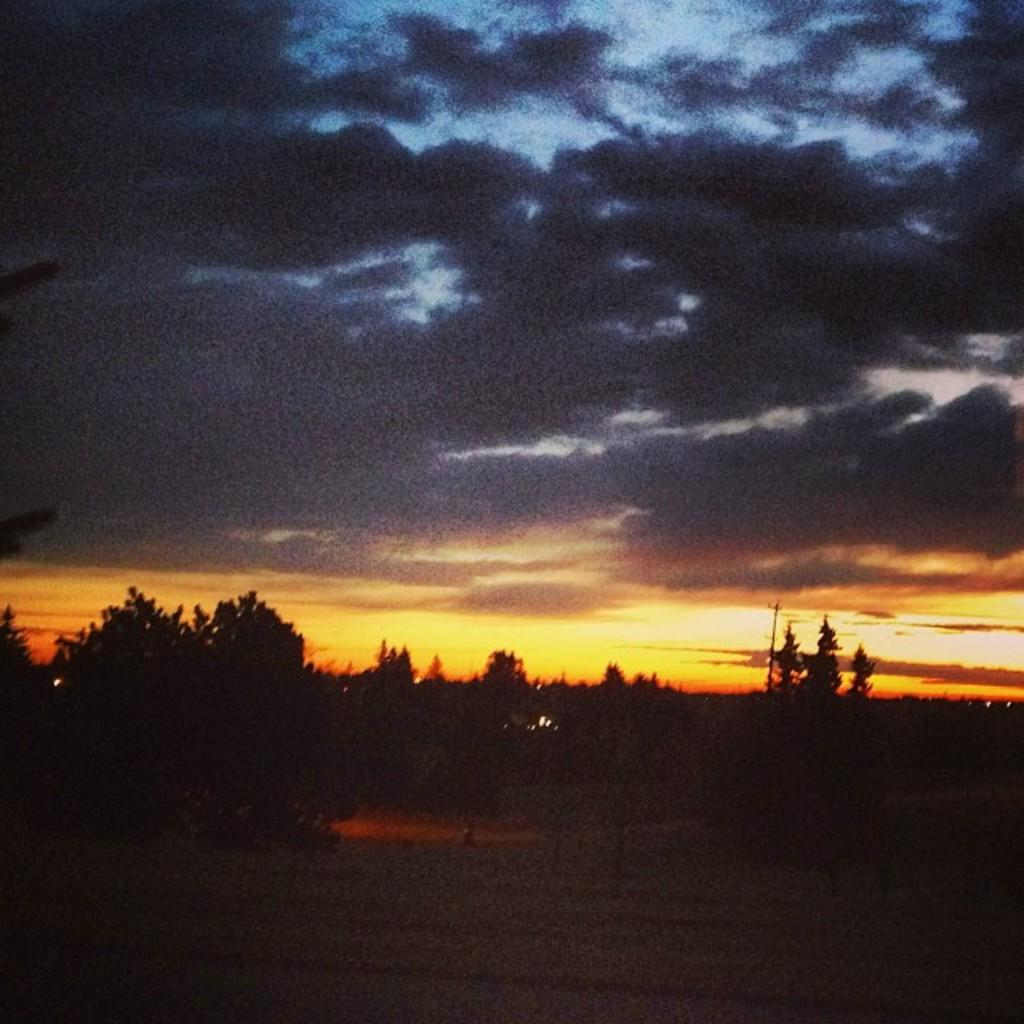What is the overall lighting condition in the image? The image is dark. What type of surface can be seen in the image? There is ground visible in the image. What type of vegetation is present in the image? There are trees in the image. What is visible in the background of the image? The sky is visible in the background of the image. What colors can be seen in the sky in the image? The sky has various colors, including black, blue, yellow, and orange. How does the slope of the ground affect the start of a race in the image? There is no race or slope present in the image; it features a dark scene with ground, trees, and a colorful sky. 